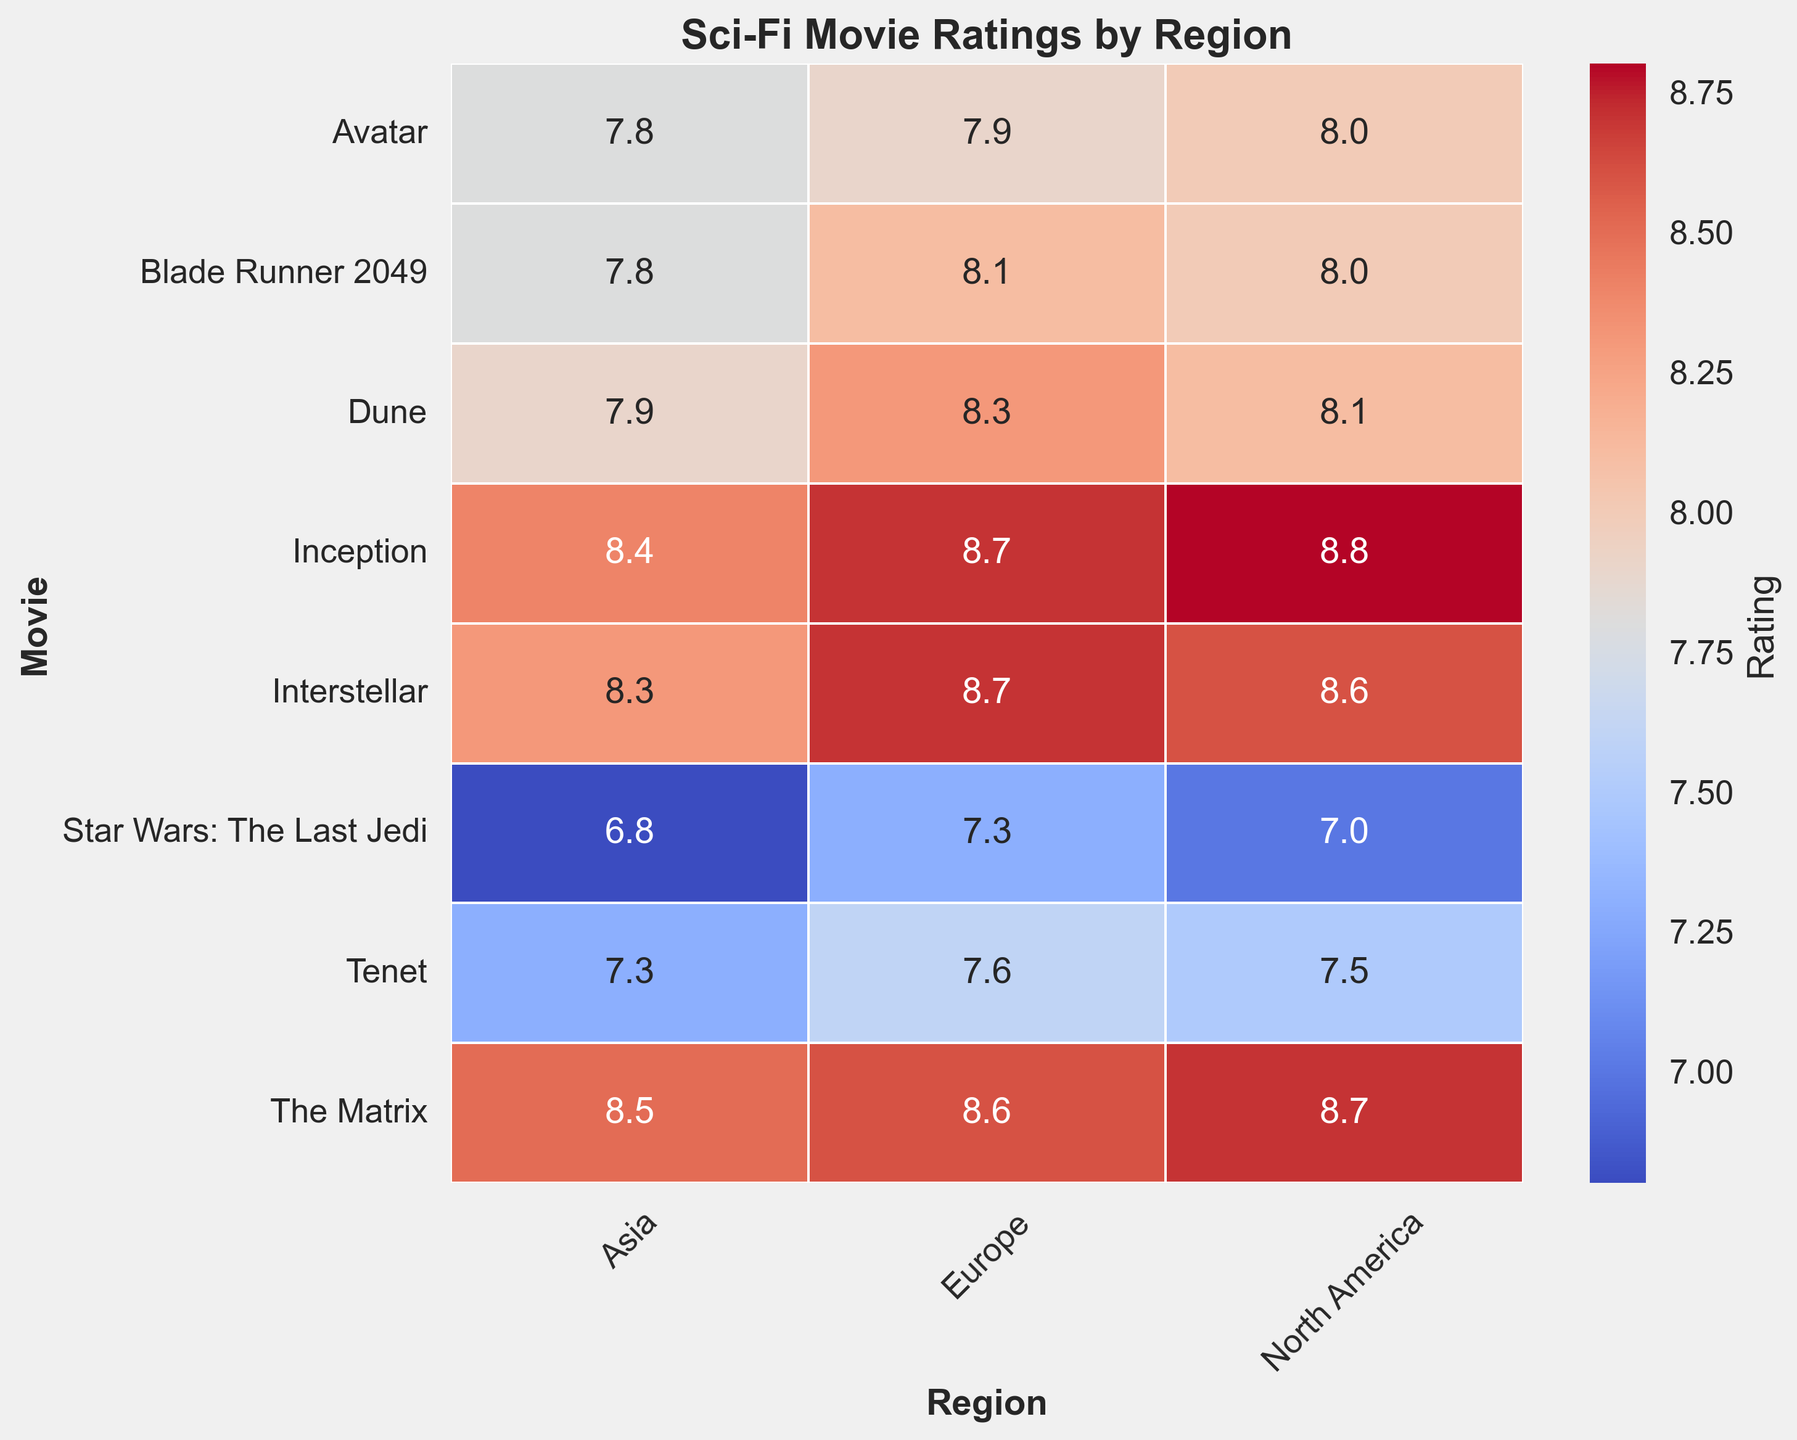What's the highest viewer rating for "Interstellar" and in which region was it received? The highest rating for "Interstellar" can be determined by looking at the corresponding row for the movie and identifying the highest value among the regions. In "Interstellar" row, the highest ratings are North America (8.6), Europe (8.7), and Asia (8.3). Therefore, the highest rating is 8.7, received in Europe.
Answer: 8.7 in Europe Which movie received the lowest viewer rating in North America and what was that rating? To find the lowest rating in North America, look down the "North America" column and identify the minimum value. The ratings are 8.0, 8.6, 8.7, 8.8, 8.0, 7.5, 7.0, and 8.1. The lowest rating among these is 7.0 for "Star Wars: The Last Jedi".
Answer: 7.0 for "Star Wars: The Last Jedi" Are there any movies that received the same viewer rating across all regions? To determine if any movie received the same rating across all regions, check each row to see if all the values are identical. For all rows, the viewer ratings differ by region. No movie received the same rating in all regions.
Answer: None How many movies have a rating of 8.0 or higher in North America? To find the number of movies with a rating of 8.0 or higher in North America, count the values in the "North America" column that meet this condition. In the "North America" column, the ratings are 8.0, 8.6, 8.7, 8.8, 8.0, 7.5, 7.0, and 8.1. The ones 8.0 or higher are: Blade Runner 2049, Interstellar, The Matrix, Inception, Avatar, and Dune. There are 6 such movies.
Answer: 6 Which region generally has the highest average viewer rating for sci-fi movies? Compute the average rating for each region by summing up the ratings in each column and dividing by the number of movies. North America's total sum is 8.0+8.6+8.7+8.8+8.0+7.5+7.0+8.1 = 56.7. Europe’s total sum is 8.1+8.7+8.6+8.7+7.9+7.6+7.3+8.3 = 65.2. Asia’s total sum is 7.8+8.3+8.5+8.4+7.8+7.3+6.8+7.9 = 62.8. There are 8 movies for each region, so the averages are North America = 56.7/8 = 7.1, Europe = 65.2/8 = 8.15, Asia = 62.8/8 = 7.85. Europe has the highest average viewer rating.
Answer: Europe What is the difference between the highest and lowest viewer ratings for "Blade Runner 2049"? To find the difference, identify the highest and lowest ratings for "Blade Runner 2049" then subtract the lowest from the highest. The ratings are North America (8.0), Europe (8.1), and Asia (7.8). The highest is 8.1 and the lowest is 7.8. The difference is 8.1 - 7.8 = 0.3.
Answer: 0.3 Which movie received the most consistent ratings across all three regions? Consistency can be determined by finding the smallest range between the highest and lowest ratings for each movie. Calculate the range for each movie:
Blade Runner 2049: 8.1-7.8 = 0.3;
Interstellar: 8.7-8.3 = 0.4;
The Matrix: 8.7-8.5 = 0.2;
Inception: 8.8-8.4 = 0.4;
Avatar: 8.0-7.8 = 0.2;
Tenet: 7.6-7.3 = 0.3;
Star Wars: The Last Jedi: 7.3-6.8 = 0.5;
Dune: 8.3-7.9 = 0.4. 
The Matrix and Avatar both have the smallest range of 0.2.
Answer: The Matrix and Avatar What is the median viewer rating for "Inception" across all regions? The median value is the middle value in an ordered list. The ratings for "Inception" are North America (8.8), Europe (8.7), and Asia (8.4). Order them: 8.4, 8.7, 8.8. The middle value is 8.7.
Answer: 8.7 Of the movies released in 2020 or later, which received the highest rating and in which region? Focus on the movies released in 2020 or later: "Tenet" and "Dune". Check their ratings across regions: 
Tenet - North America (7.5), Europe (7.6), Asia (7.3); 
Dune - North America (8.1), Europe (8.3), Asia (7.9). 
The highest rating is "Dune" (8.3) in Europe.
Answer: Dune with 8.3 in Europe 